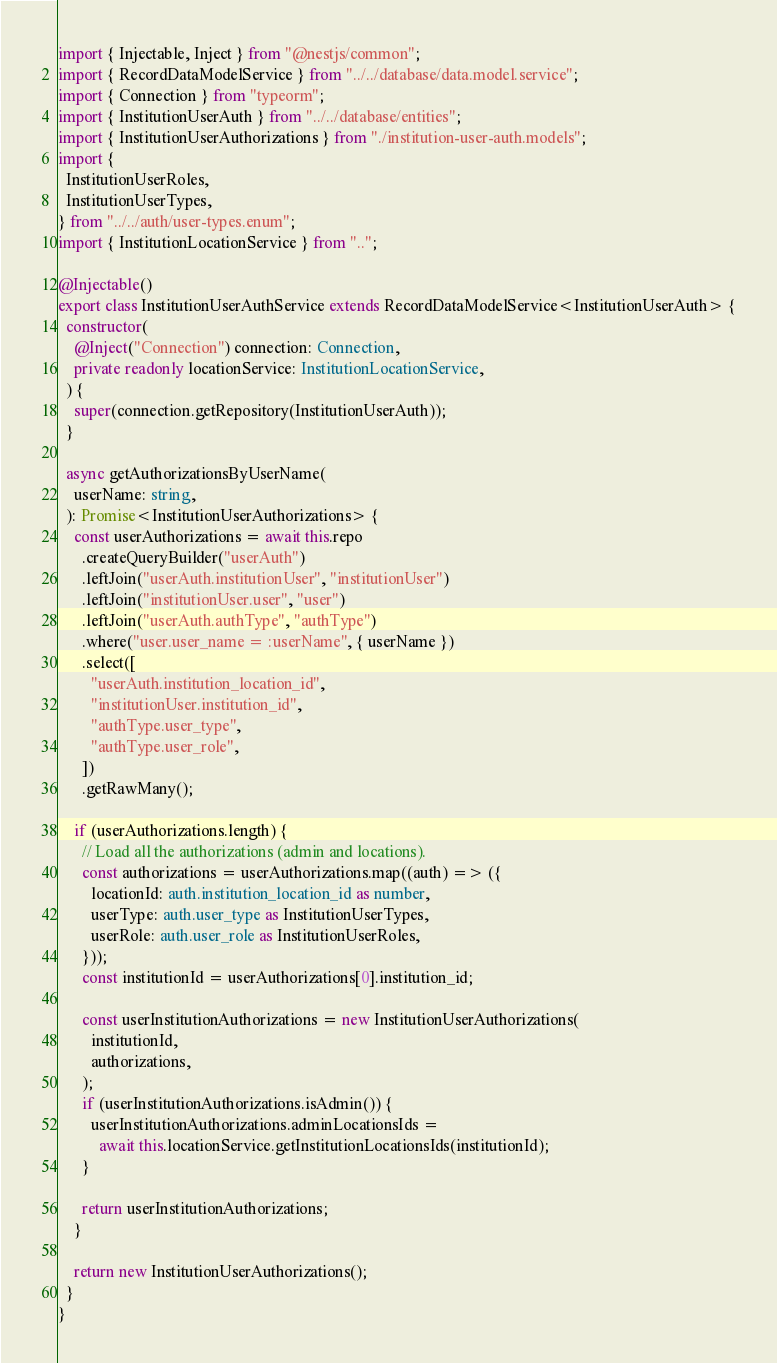<code> <loc_0><loc_0><loc_500><loc_500><_TypeScript_>import { Injectable, Inject } from "@nestjs/common";
import { RecordDataModelService } from "../../database/data.model.service";
import { Connection } from "typeorm";
import { InstitutionUserAuth } from "../../database/entities";
import { InstitutionUserAuthorizations } from "./institution-user-auth.models";
import {
  InstitutionUserRoles,
  InstitutionUserTypes,
} from "../../auth/user-types.enum";
import { InstitutionLocationService } from "..";

@Injectable()
export class InstitutionUserAuthService extends RecordDataModelService<InstitutionUserAuth> {
  constructor(
    @Inject("Connection") connection: Connection,
    private readonly locationService: InstitutionLocationService,
  ) {
    super(connection.getRepository(InstitutionUserAuth));
  }

  async getAuthorizationsByUserName(
    userName: string,
  ): Promise<InstitutionUserAuthorizations> {
    const userAuthorizations = await this.repo
      .createQueryBuilder("userAuth")
      .leftJoin("userAuth.institutionUser", "institutionUser")
      .leftJoin("institutionUser.user", "user")
      .leftJoin("userAuth.authType", "authType")
      .where("user.user_name = :userName", { userName })
      .select([
        "userAuth.institution_location_id",
        "institutionUser.institution_id",
        "authType.user_type",
        "authType.user_role",
      ])
      .getRawMany();

    if (userAuthorizations.length) {
      // Load all the authorizations (admin and locations).
      const authorizations = userAuthorizations.map((auth) => ({
        locationId: auth.institution_location_id as number,
        userType: auth.user_type as InstitutionUserTypes,
        userRole: auth.user_role as InstitutionUserRoles,
      }));
      const institutionId = userAuthorizations[0].institution_id;

      const userInstitutionAuthorizations = new InstitutionUserAuthorizations(
        institutionId,
        authorizations,
      );
      if (userInstitutionAuthorizations.isAdmin()) {
        userInstitutionAuthorizations.adminLocationsIds =
          await this.locationService.getInstitutionLocationsIds(institutionId);
      }

      return userInstitutionAuthorizations;
    }

    return new InstitutionUserAuthorizations();
  }
}
</code> 